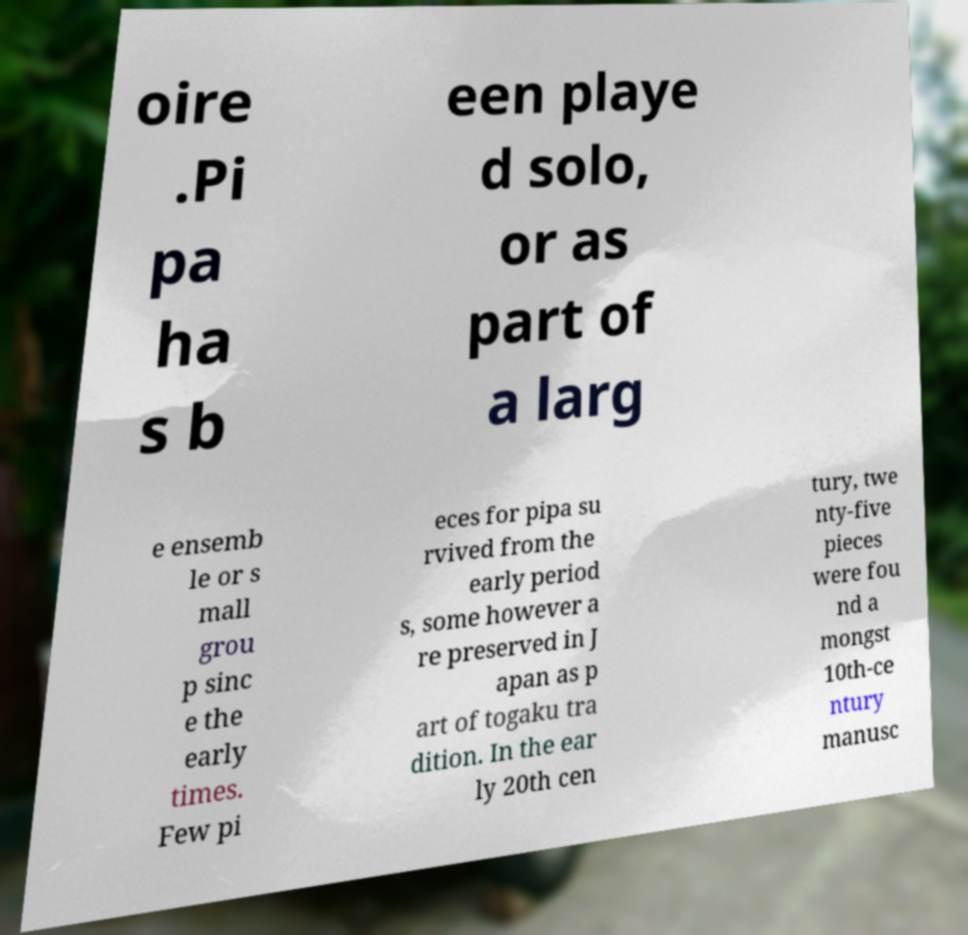Could you assist in decoding the text presented in this image and type it out clearly? oire .Pi pa ha s b een playe d solo, or as part of a larg e ensemb le or s mall grou p sinc e the early times. Few pi eces for pipa su rvived from the early period s, some however a re preserved in J apan as p art of togaku tra dition. In the ear ly 20th cen tury, twe nty-five pieces were fou nd a mongst 10th-ce ntury manusc 